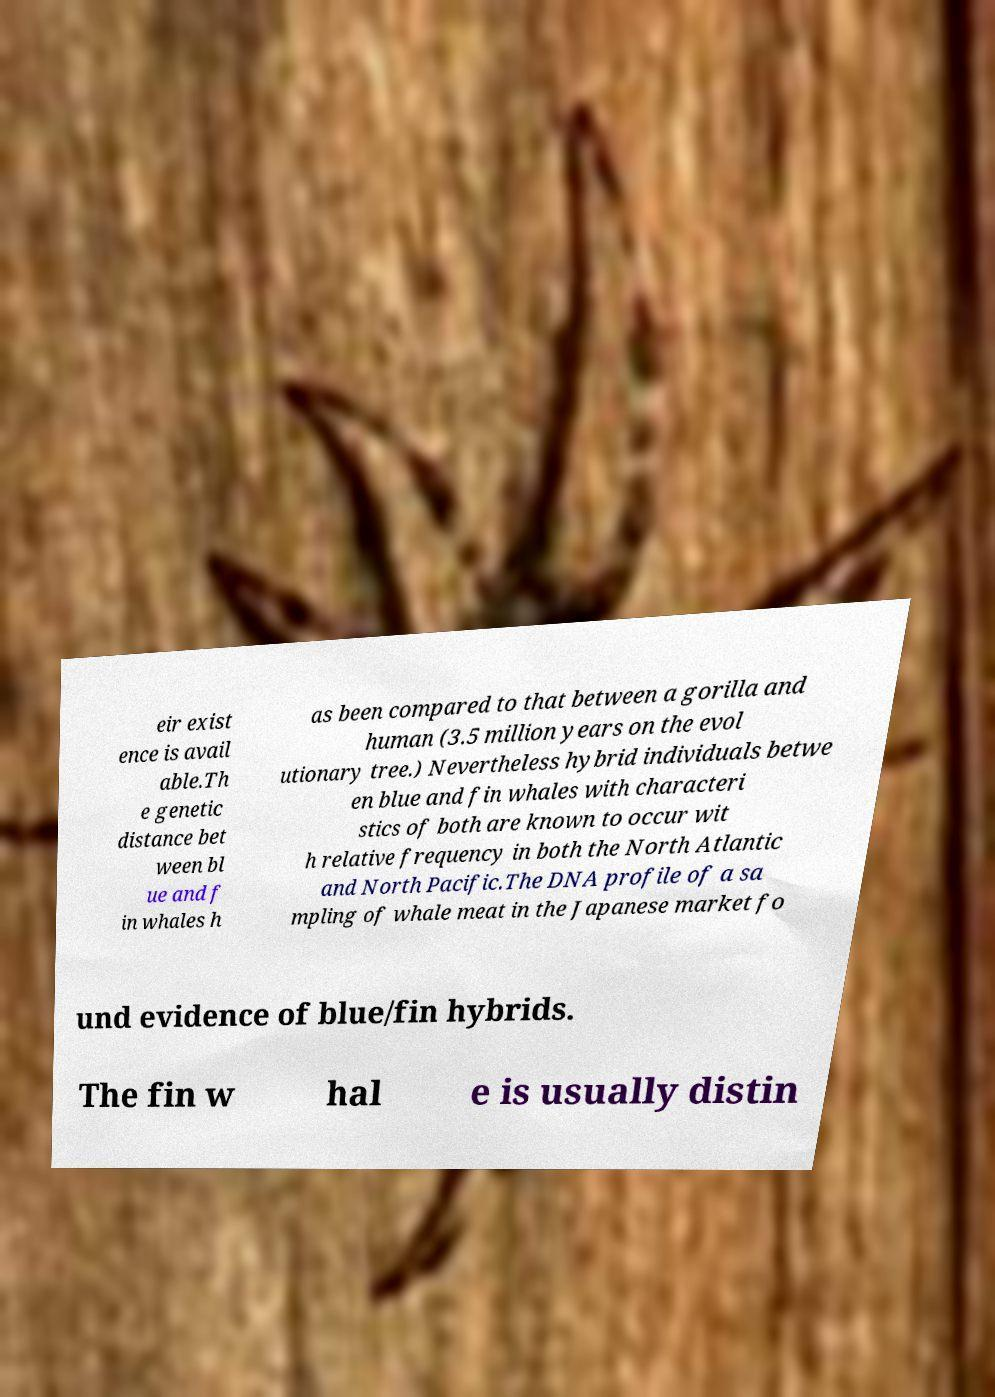Please read and relay the text visible in this image. What does it say? eir exist ence is avail able.Th e genetic distance bet ween bl ue and f in whales h as been compared to that between a gorilla and human (3.5 million years on the evol utionary tree.) Nevertheless hybrid individuals betwe en blue and fin whales with characteri stics of both are known to occur wit h relative frequency in both the North Atlantic and North Pacific.The DNA profile of a sa mpling of whale meat in the Japanese market fo und evidence of blue/fin hybrids. The fin w hal e is usually distin 